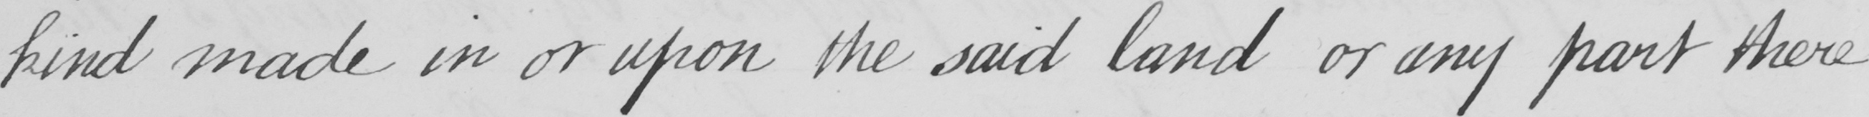Please transcribe the handwritten text in this image. kind made in or upon said land or any part thereof 